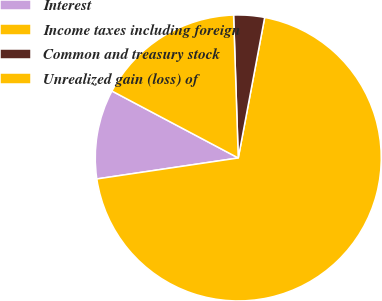<chart> <loc_0><loc_0><loc_500><loc_500><pie_chart><fcel>Interest<fcel>Income taxes including foreign<fcel>Common and treasury stock<fcel>Unrealized gain (loss) of<nl><fcel>10.1%<fcel>69.69%<fcel>3.48%<fcel>16.72%<nl></chart> 